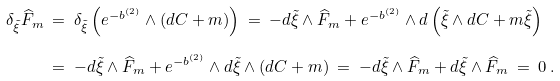<formula> <loc_0><loc_0><loc_500><loc_500>\delta _ { \tilde { \xi } } \widehat { F } _ { m } & \ = \ \delta _ { \tilde { \xi } } \left ( e ^ { - b ^ { ( 2 ) } } \wedge ( d C + m ) \right ) \ = \ - d \tilde { \xi } \wedge \widehat { F } _ { m } + e ^ { - b ^ { ( 2 ) } } \wedge d \left ( \tilde { \xi } \wedge d C + m \tilde { \xi } \right ) \\ & \ = \ - d \tilde { \xi } \wedge \widehat { F } _ { m } + e ^ { - b ^ { ( 2 ) } } \wedge d \tilde { \xi } \wedge ( d C + m ) \ = \ - d \tilde { \xi } \wedge \widehat { F } _ { m } + d \tilde { \xi } \wedge \widehat { F } _ { m } \ = \ 0 \, .</formula> 